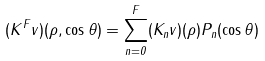Convert formula to latex. <formula><loc_0><loc_0><loc_500><loc_500>( K ^ { F } v ) ( \rho , \cos \theta ) = \sum ^ { F } _ { n = 0 } ( K _ { n } v ) ( \rho ) P _ { n } ( \cos \theta )</formula> 